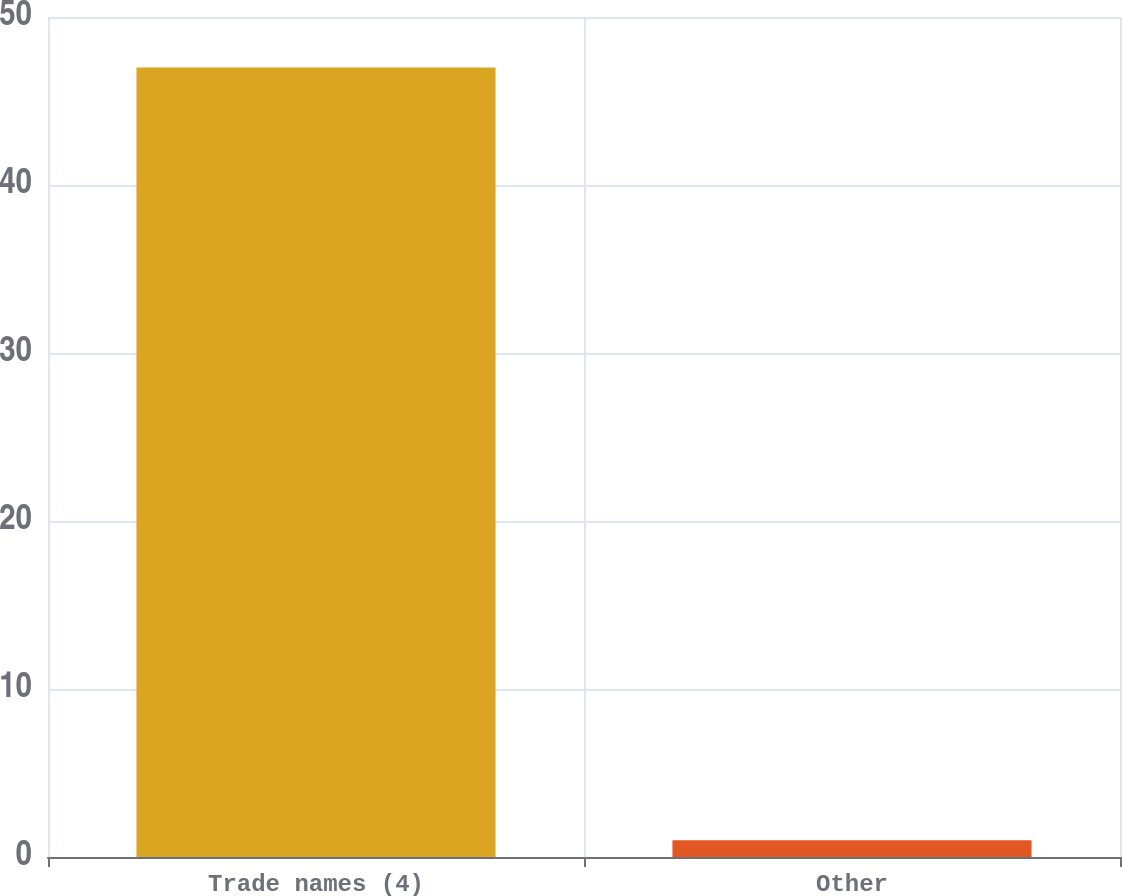Convert chart. <chart><loc_0><loc_0><loc_500><loc_500><bar_chart><fcel>Trade names (4)<fcel>Other<nl><fcel>47<fcel>1<nl></chart> 